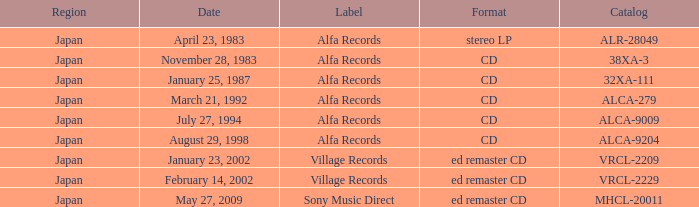Which date is in stereo lp format? April 23, 1983. 